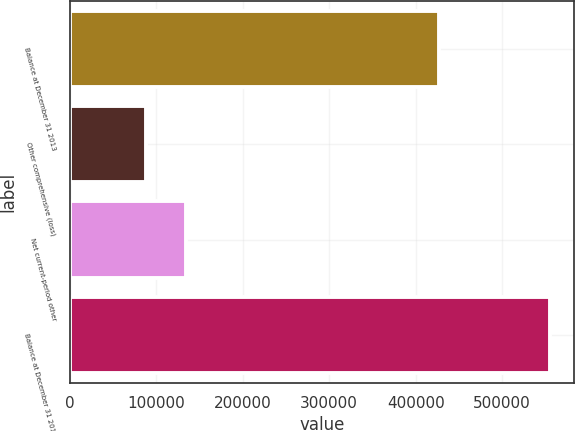Convert chart. <chart><loc_0><loc_0><loc_500><loc_500><bar_chart><fcel>Balance at December 31 2013<fcel>Other comprehensive (loss)<fcel>Net current-period other<fcel>Balance at December 31 2014<nl><fcel>426830<fcel>88088<fcel>134856<fcel>555767<nl></chart> 